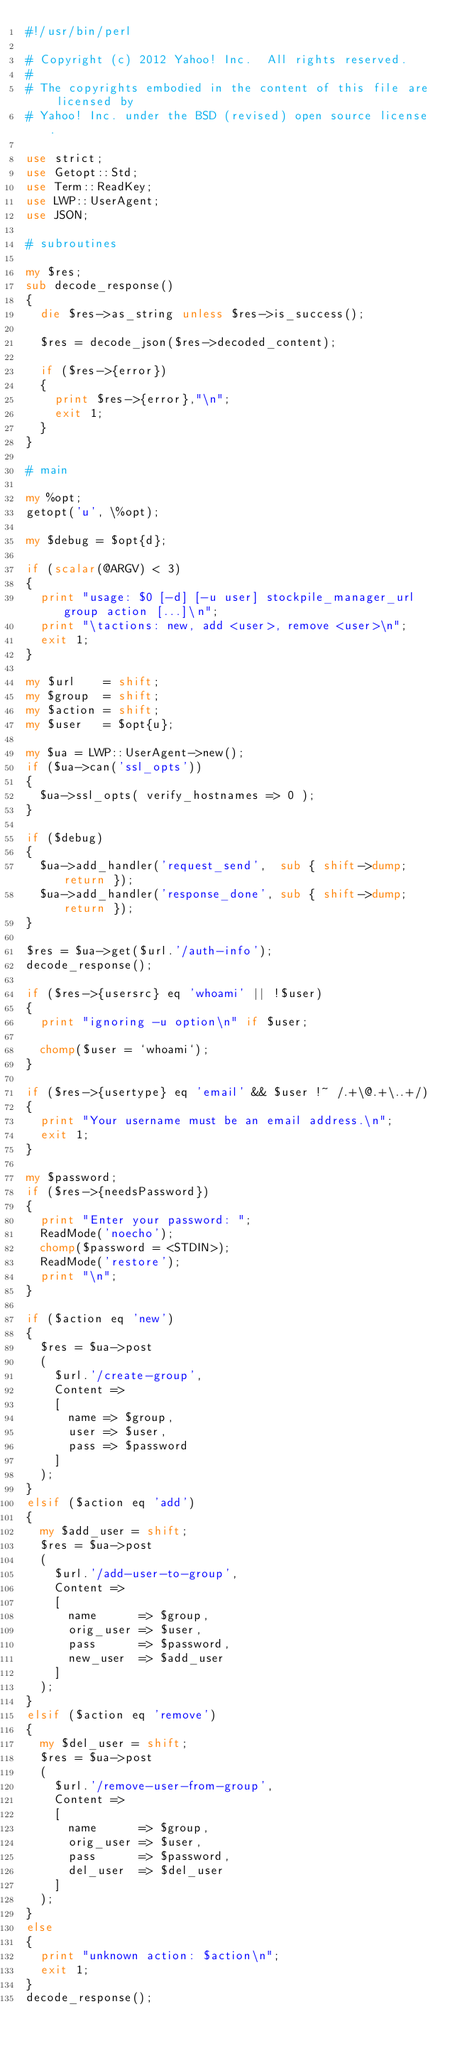Convert code to text. <code><loc_0><loc_0><loc_500><loc_500><_Perl_>#!/usr/bin/perl

# Copyright (c) 2012 Yahoo! Inc.  All rights reserved.
#
# The copyrights embodied in the content of this file are licensed by
# Yahoo! Inc. under the BSD (revised) open source license.

use strict;
use Getopt::Std;
use Term::ReadKey;
use LWP::UserAgent;
use JSON;

# subroutines

my $res;
sub decode_response()
{
	die $res->as_string unless $res->is_success();

	$res = decode_json($res->decoded_content);

	if ($res->{error})
	{
		print $res->{error},"\n";
		exit 1;
	}
}

# main

my %opt;
getopt('u', \%opt);

my $debug = $opt{d};

if (scalar(@ARGV) < 3)
{
	print "usage: $0 [-d] [-u user] stockpile_manager_url group action [...]\n";
	print "\tactions: new, add <user>, remove <user>\n";
	exit 1;
}

my $url    = shift;
my $group  = shift;
my $action = shift;
my $user   = $opt{u};

my $ua = LWP::UserAgent->new();
if ($ua->can('ssl_opts'))
{
	$ua->ssl_opts( verify_hostnames => 0 );
}

if ($debug)
{
	$ua->add_handler('request_send',  sub { shift->dump; return });
	$ua->add_handler('response_done', sub { shift->dump; return });
}

$res = $ua->get($url.'/auth-info');
decode_response();

if ($res->{usersrc} eq 'whoami' || !$user)
{
	print "ignoring -u option\n" if $user;

	chomp($user = `whoami`);
}

if ($res->{usertype} eq 'email' && $user !~ /.+\@.+\..+/)
{
	print "Your username must be an email address.\n";
	exit 1;
}

my $password;
if ($res->{needsPassword})
{
	print "Enter your password: ";
	ReadMode('noecho');
	chomp($password = <STDIN>);
	ReadMode('restore');
	print "\n";
}

if ($action eq 'new')
{
	$res = $ua->post
	(
		$url.'/create-group',
		Content =>
		[
			name => $group,
			user => $user,
			pass => $password
		]
	);
}
elsif ($action eq 'add')
{
	my $add_user = shift;
	$res = $ua->post
	(
		$url.'/add-user-to-group',
		Content =>
		[
			name      => $group,
			orig_user => $user,
			pass      => $password,
			new_user  => $add_user
		]
	);
}
elsif ($action eq 'remove')
{
	my $del_user = shift;
	$res = $ua->post
	(
		$url.'/remove-user-from-group',
		Content =>
		[
			name      => $group,
			orig_user => $user,
			pass      => $password,
			del_user  => $del_user
		]
	);
}
else
{
	print "unknown action: $action\n";
	exit 1;
}
decode_response();
</code> 